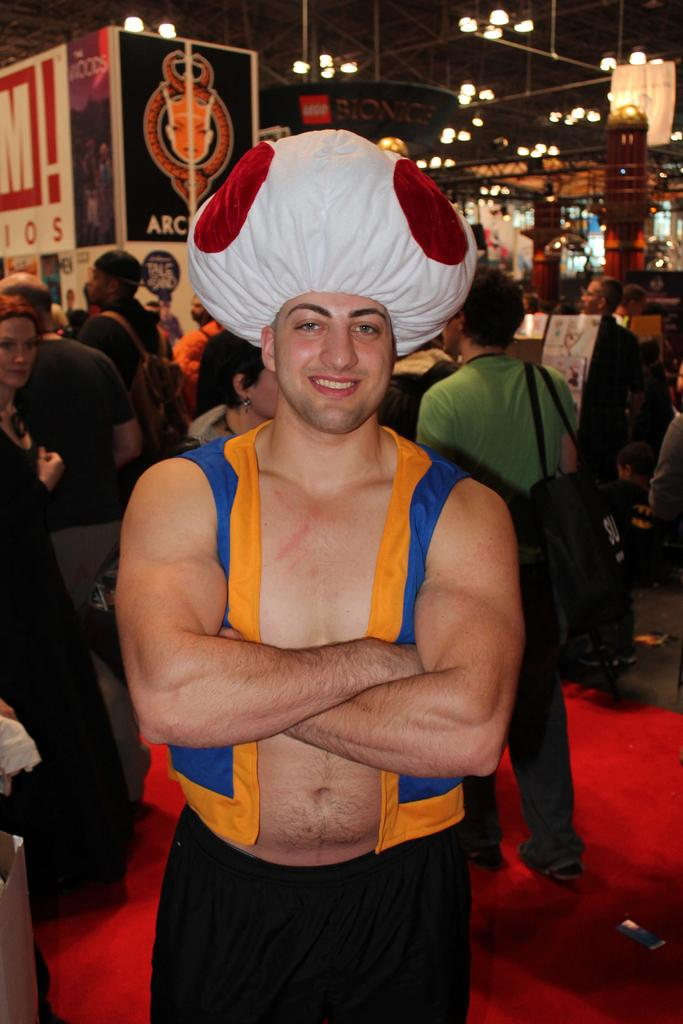Who is the main subject in the image? There is a man in the center of the image. What is the man wearing in the image? The man appears to be wearing a costume. Can you describe the background of the image? There are people, light, other objects, posters, and a roof visible in the background of the image. What type of toothpaste is the man using in the image? There is no toothpaste present in the image; the man is wearing a costume. How many spades can be seen in the image? There are no spades visible in the image. 